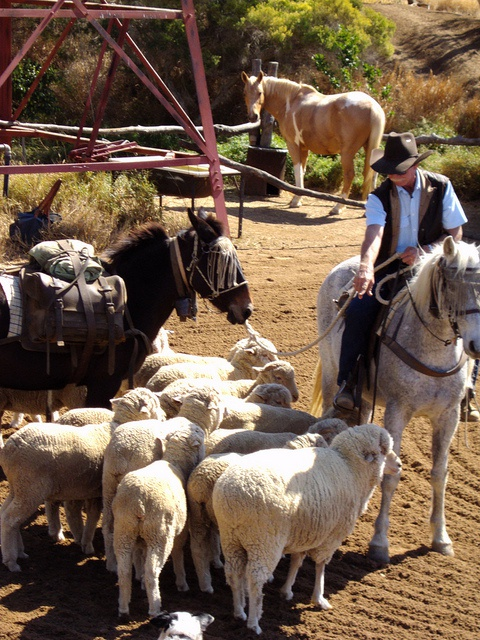Describe the objects in this image and their specific colors. I can see horse in maroon, black, gray, and ivory tones, sheep in maroon, gray, and white tones, horse in maroon, gray, and black tones, people in maroon, black, gray, and darkgray tones, and sheep in maroon, black, and ivory tones in this image. 